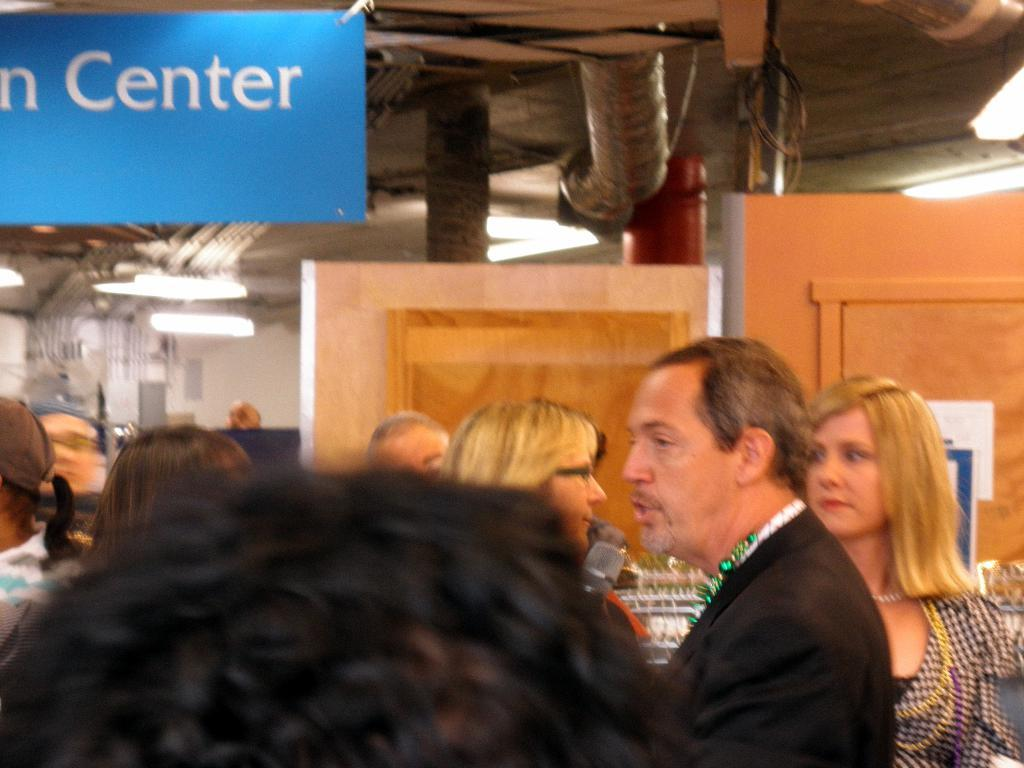How many people are in the group visible in the image? There is a group of people in the image, but the exact number cannot be determined from the provided facts. What is the man holding in the image? The man is holding a mic in the image. What type of doors can be seen in the image? There are wooden doors visible in the image. What is the purpose of the board in the image? The purpose of the board in the image cannot be determined from the provided facts. What is the background of the image made of? The background of the image includes a wall and ceiling lights. What is the structure above the group of people in the image? There is a roof in the image. How many eggs are visible on the feet of the people in the image? There are no eggs or feet visible in the image; it features a group of people, a man holding a mic, wooden doors, a board, a wall, ceiling lights, and a roof. 